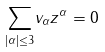Convert formula to latex. <formula><loc_0><loc_0><loc_500><loc_500>\underset { \left | \alpha \right | \leq 3 } { \sum } v _ { \alpha } z ^ { \alpha } = 0</formula> 